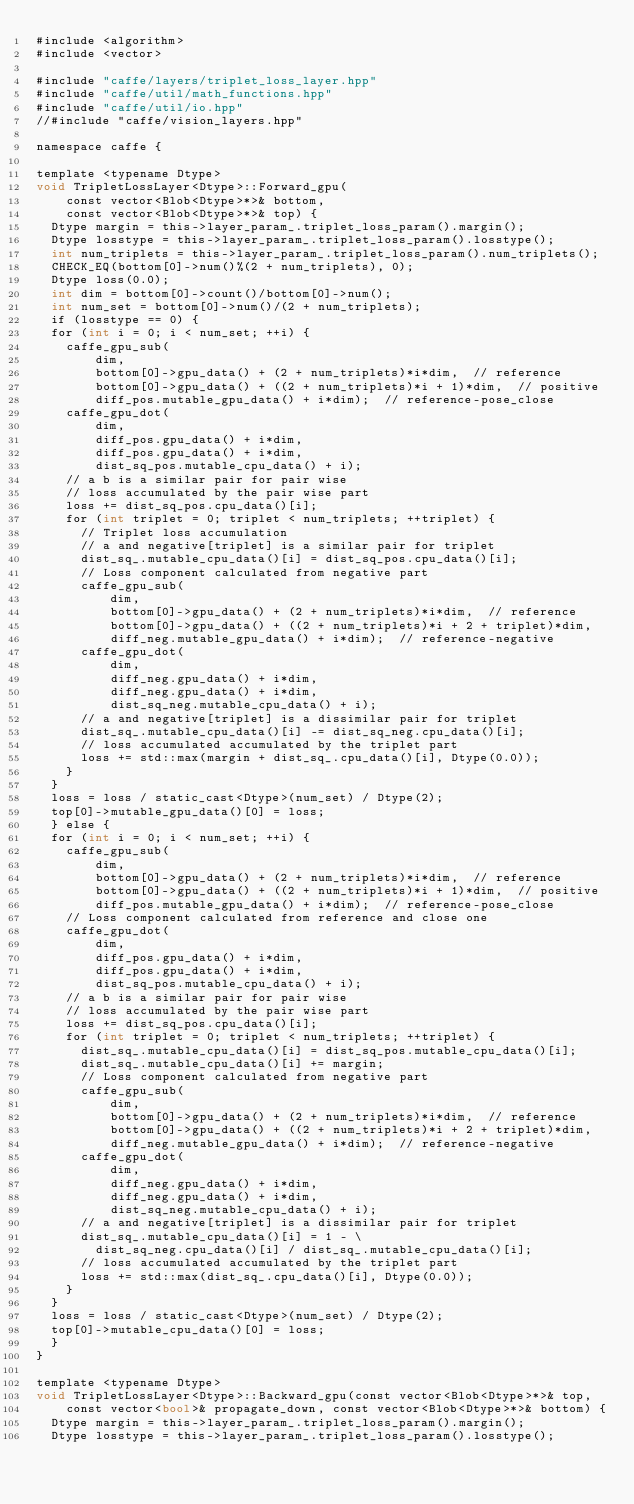<code> <loc_0><loc_0><loc_500><loc_500><_Cuda_>#include <algorithm>
#include <vector>

#include "caffe/layers/triplet_loss_layer.hpp"
#include "caffe/util/math_functions.hpp"
#include "caffe/util/io.hpp"
//#include "caffe/vision_layers.hpp"

namespace caffe {

template <typename Dtype>
void TripletLossLayer<Dtype>::Forward_gpu(
    const vector<Blob<Dtype>*>& bottom,
    const vector<Blob<Dtype>*>& top) {
  Dtype margin = this->layer_param_.triplet_loss_param().margin();
  Dtype losstype = this->layer_param_.triplet_loss_param().losstype();
  int num_triplets = this->layer_param_.triplet_loss_param().num_triplets();
  CHECK_EQ(bottom[0]->num()%(2 + num_triplets), 0);
  Dtype loss(0.0);
  int dim = bottom[0]->count()/bottom[0]->num();
  int num_set = bottom[0]->num()/(2 + num_triplets);
  if (losstype == 0) {
  for (int i = 0; i < num_set; ++i) {
    caffe_gpu_sub(
        dim,
        bottom[0]->gpu_data() + (2 + num_triplets)*i*dim,  // reference
        bottom[0]->gpu_data() + ((2 + num_triplets)*i + 1)*dim,  // positive
        diff_pos.mutable_gpu_data() + i*dim);  // reference-pose_close
    caffe_gpu_dot(
        dim,
        diff_pos.gpu_data() + i*dim,
        diff_pos.gpu_data() + i*dim,
        dist_sq_pos.mutable_cpu_data() + i);
    // a b is a similar pair for pair wise
    // loss accumulated by the pair wise part
    loss += dist_sq_pos.cpu_data()[i];
    for (int triplet = 0; triplet < num_triplets; ++triplet) {
      // Triplet loss accumulation
      // a and negative[triplet] is a similar pair for triplet
      dist_sq_.mutable_cpu_data()[i] = dist_sq_pos.cpu_data()[i];
      // Loss component calculated from negative part
      caffe_gpu_sub(
          dim,
          bottom[0]->gpu_data() + (2 + num_triplets)*i*dim,  // reference
          bottom[0]->gpu_data() + ((2 + num_triplets)*i + 2 + triplet)*dim,
          diff_neg.mutable_gpu_data() + i*dim);  // reference-negative
      caffe_gpu_dot(
          dim,
          diff_neg.gpu_data() + i*dim,
          diff_neg.gpu_data() + i*dim,
          dist_sq_neg.mutable_cpu_data() + i);
      // a and negative[triplet] is a dissimilar pair for triplet
      dist_sq_.mutable_cpu_data()[i] -= dist_sq_neg.cpu_data()[i];
      // loss accumulated accumulated by the triplet part
      loss += std::max(margin + dist_sq_.cpu_data()[i], Dtype(0.0));
    }
  }
  loss = loss / static_cast<Dtype>(num_set) / Dtype(2);
  top[0]->mutable_gpu_data()[0] = loss;
  } else {
  for (int i = 0; i < num_set; ++i) {
    caffe_gpu_sub(
        dim,
        bottom[0]->gpu_data() + (2 + num_triplets)*i*dim,  // reference
        bottom[0]->gpu_data() + ((2 + num_triplets)*i + 1)*dim,  // positive
        diff_pos.mutable_gpu_data() + i*dim);  // reference-pose_close
    // Loss component calculated from reference and close one
    caffe_gpu_dot(
        dim,
        diff_pos.gpu_data() + i*dim,
        diff_pos.gpu_data() + i*dim,
        dist_sq_pos.mutable_cpu_data() + i);
    // a b is a similar pair for pair wise
    // loss accumulated by the pair wise part
    loss += dist_sq_pos.cpu_data()[i];
    for (int triplet = 0; triplet < num_triplets; ++triplet) {
      dist_sq_.mutable_cpu_data()[i] = dist_sq_pos.mutable_cpu_data()[i];
      dist_sq_.mutable_cpu_data()[i] += margin;
      // Loss component calculated from negative part
      caffe_gpu_sub(
          dim,
          bottom[0]->gpu_data() + (2 + num_triplets)*i*dim,  // reference
          bottom[0]->gpu_data() + ((2 + num_triplets)*i + 2 + triplet)*dim,
          diff_neg.mutable_gpu_data() + i*dim);  // reference-negative
      caffe_gpu_dot(
          dim,
          diff_neg.gpu_data() + i*dim,
          diff_neg.gpu_data() + i*dim,
          dist_sq_neg.mutable_cpu_data() + i);
      // a and negative[triplet] is a dissimilar pair for triplet
      dist_sq_.mutable_cpu_data()[i] = 1 - \
        dist_sq_neg.cpu_data()[i] / dist_sq_.mutable_cpu_data()[i];
      // loss accumulated accumulated by the triplet part
      loss += std::max(dist_sq_.cpu_data()[i], Dtype(0.0));
    }
  }
  loss = loss / static_cast<Dtype>(num_set) / Dtype(2);
  top[0]->mutable_cpu_data()[0] = loss;
  }
}

template <typename Dtype>
void TripletLossLayer<Dtype>::Backward_gpu(const vector<Blob<Dtype>*>& top,
    const vector<bool>& propagate_down, const vector<Blob<Dtype>*>& bottom) {
  Dtype margin = this->layer_param_.triplet_loss_param().margin();
  Dtype losstype = this->layer_param_.triplet_loss_param().losstype();</code> 